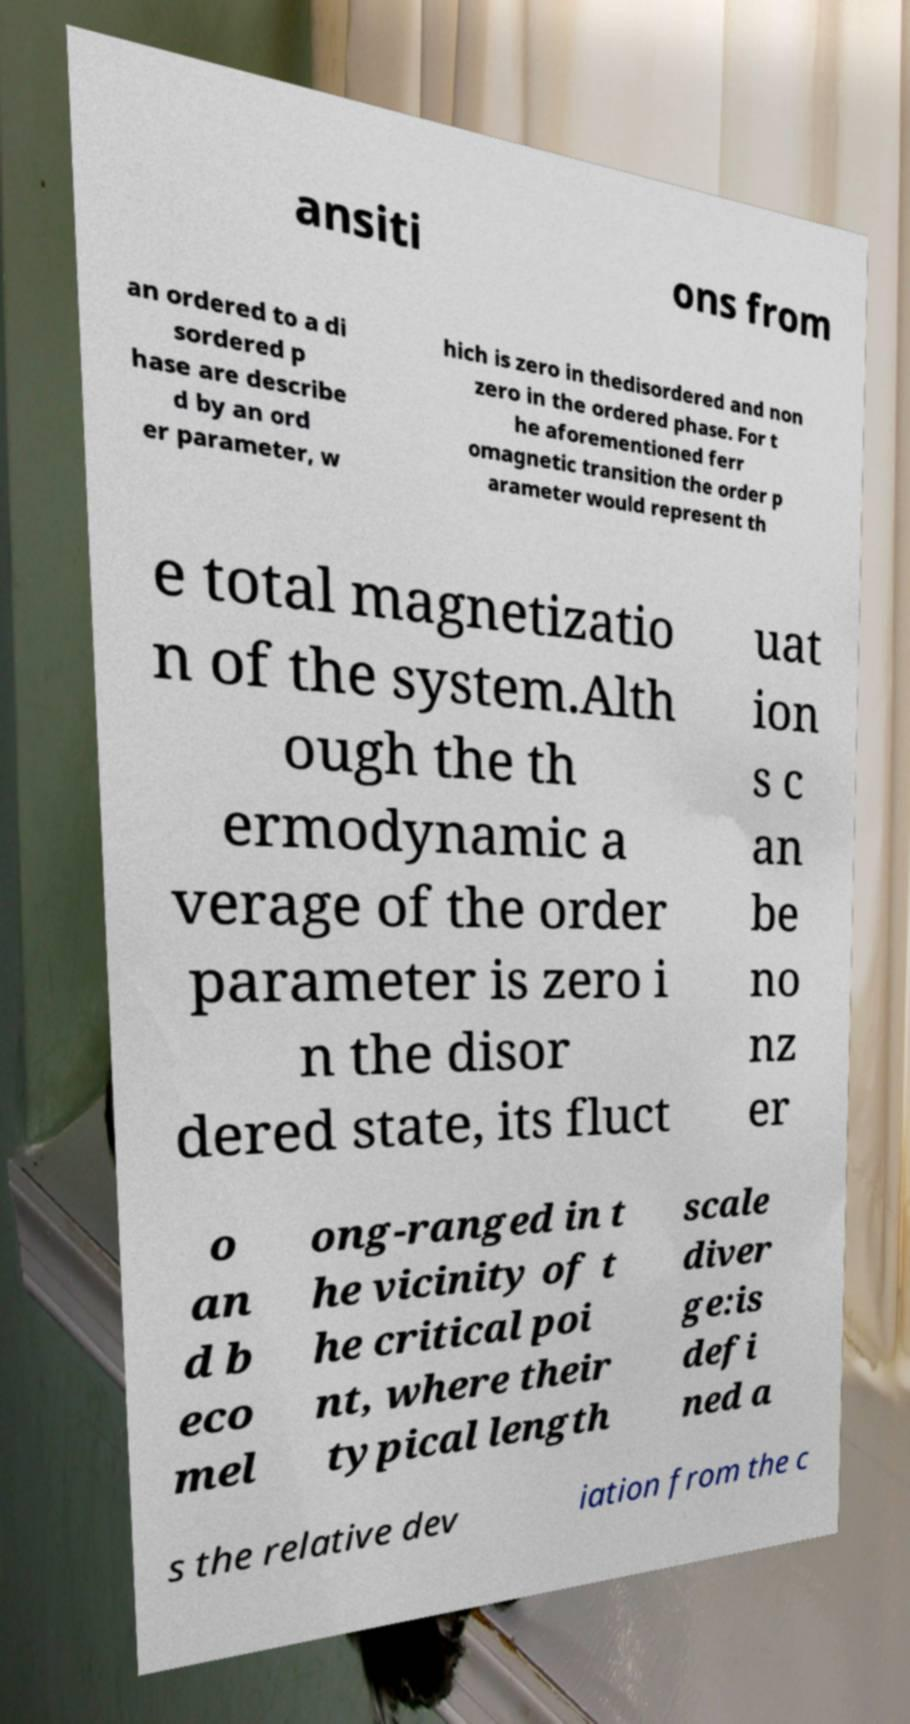Please identify and transcribe the text found in this image. ansiti ons from an ordered to a di sordered p hase are describe d by an ord er parameter, w hich is zero in thedisordered and non zero in the ordered phase. For t he aforementioned ferr omagnetic transition the order p arameter would represent th e total magnetizatio n of the system.Alth ough the th ermodynamic a verage of the order parameter is zero i n the disor dered state, its fluct uat ion s c an be no nz er o an d b eco mel ong-ranged in t he vicinity of t he critical poi nt, where their typical length scale diver ge:is defi ned a s the relative dev iation from the c 